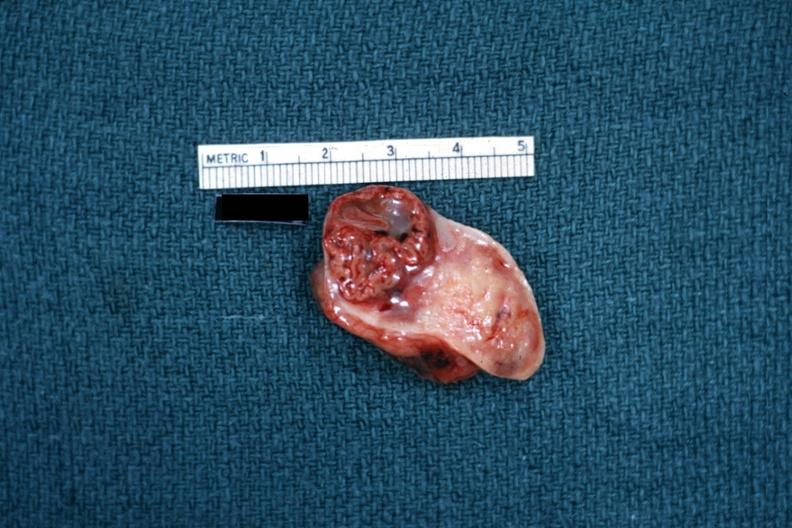s female reproductive present?
Answer the question using a single word or phrase. Yes 